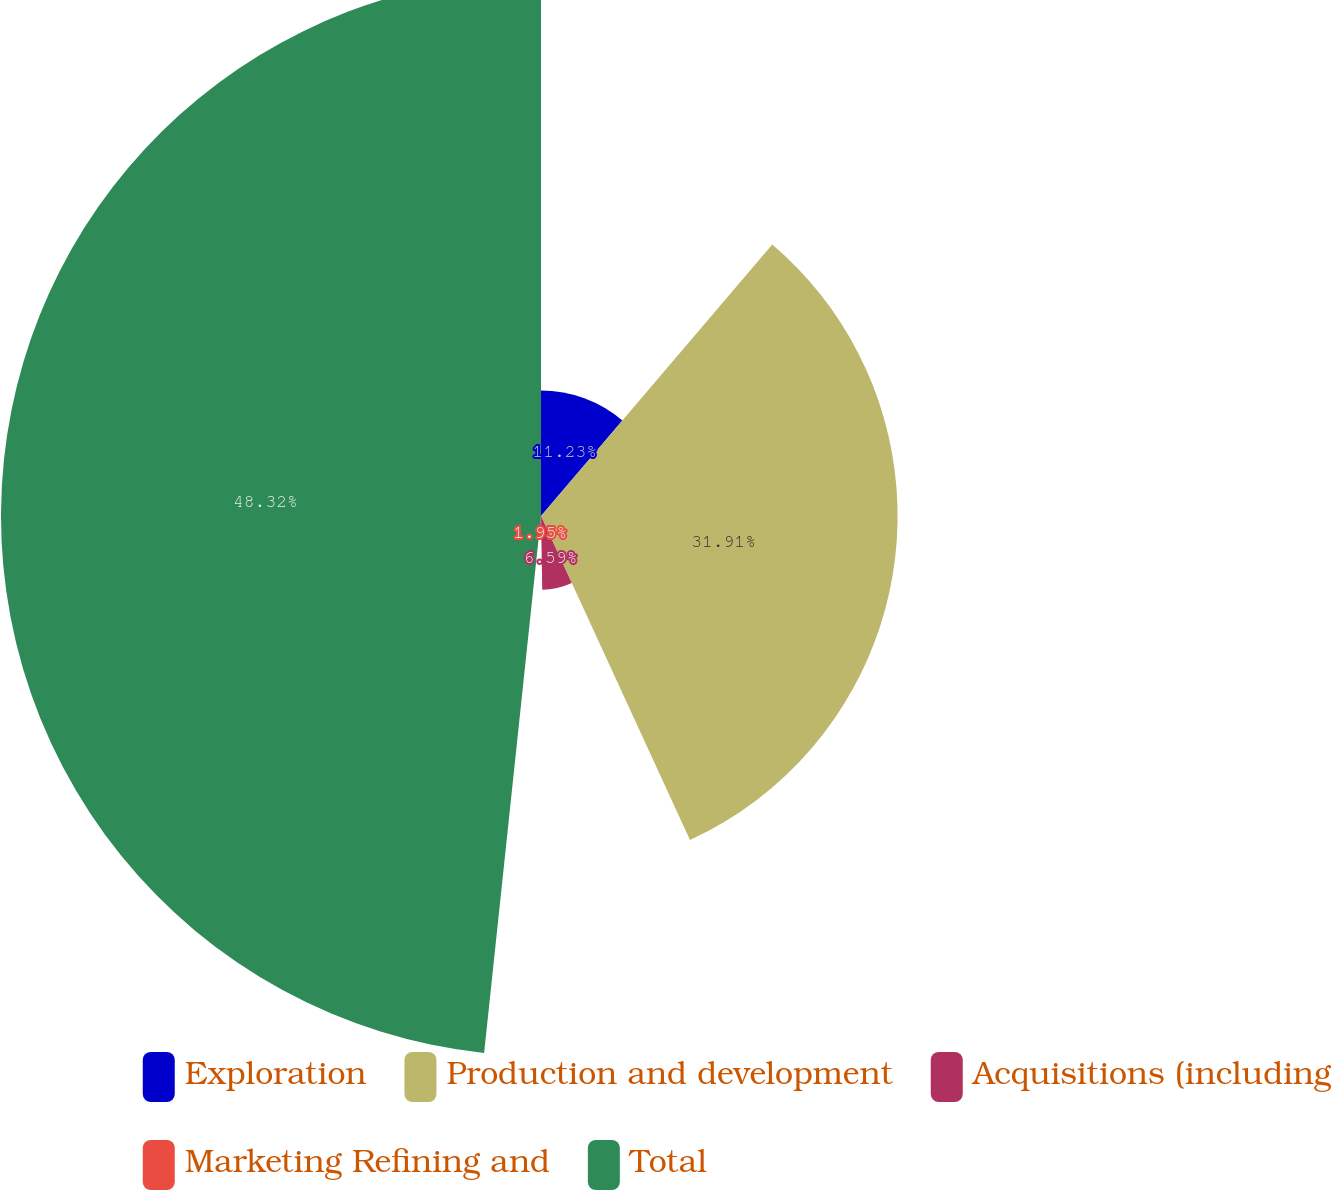Convert chart. <chart><loc_0><loc_0><loc_500><loc_500><pie_chart><fcel>Exploration<fcel>Production and development<fcel>Acquisitions (including<fcel>Marketing Refining and<fcel>Total<nl><fcel>11.23%<fcel>31.91%<fcel>6.59%<fcel>1.95%<fcel>48.32%<nl></chart> 